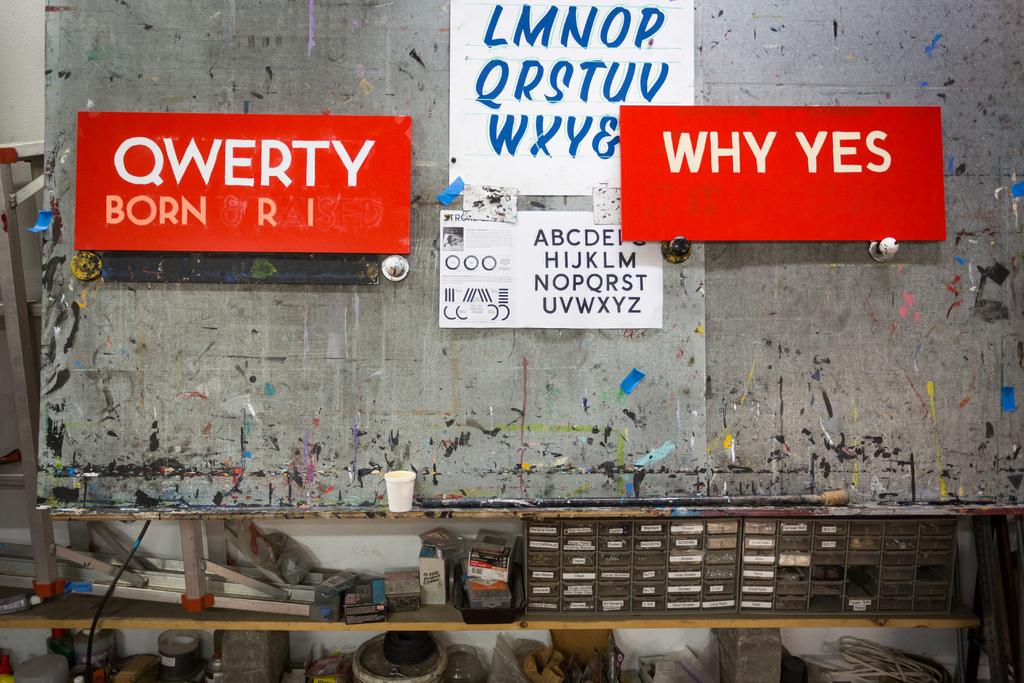What is written on the white poster?
Ensure brevity in your answer.  Conditioned. 